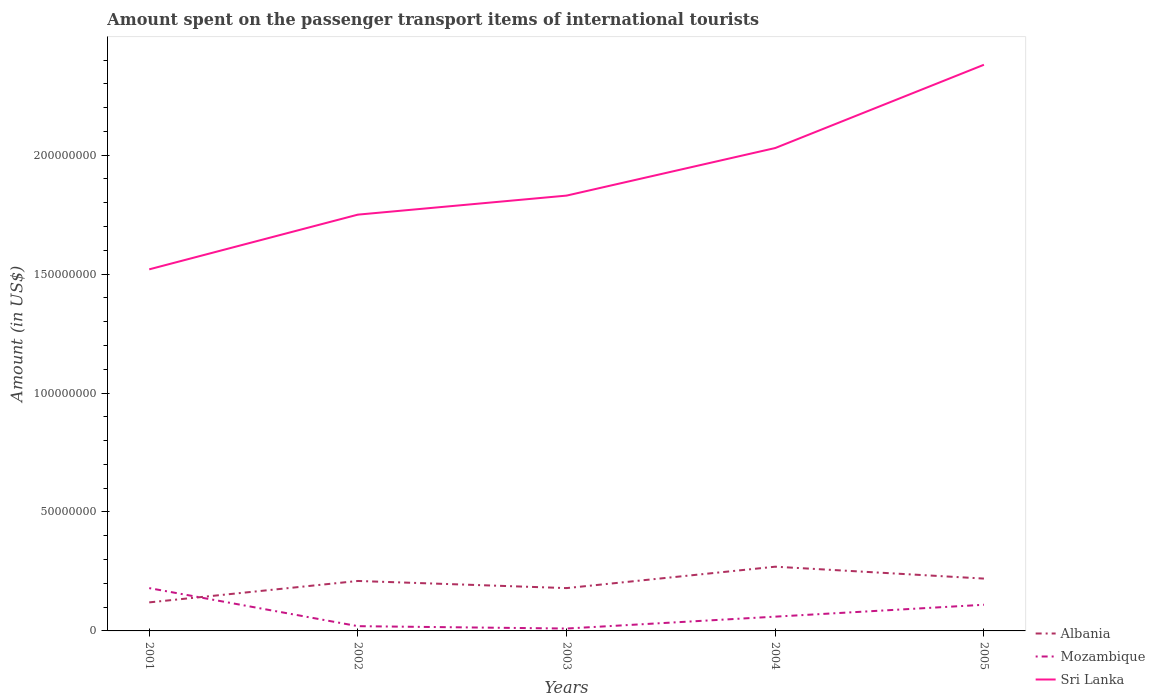Is the number of lines equal to the number of legend labels?
Ensure brevity in your answer.  Yes. Across all years, what is the maximum amount spent on the passenger transport items of international tourists in Mozambique?
Offer a terse response. 1.00e+06. In which year was the amount spent on the passenger transport items of international tourists in Mozambique maximum?
Ensure brevity in your answer.  2003. What is the total amount spent on the passenger transport items of international tourists in Albania in the graph?
Your answer should be very brief. -4.00e+06. What is the difference between the highest and the second highest amount spent on the passenger transport items of international tourists in Mozambique?
Make the answer very short. 1.70e+07. What is the difference between the highest and the lowest amount spent on the passenger transport items of international tourists in Mozambique?
Make the answer very short. 2. How many lines are there?
Offer a terse response. 3. What is the difference between two consecutive major ticks on the Y-axis?
Ensure brevity in your answer.  5.00e+07. Does the graph contain grids?
Keep it short and to the point. No. What is the title of the graph?
Your answer should be very brief. Amount spent on the passenger transport items of international tourists. What is the label or title of the X-axis?
Provide a short and direct response. Years. What is the label or title of the Y-axis?
Keep it short and to the point. Amount (in US$). What is the Amount (in US$) of Mozambique in 2001?
Your answer should be compact. 1.80e+07. What is the Amount (in US$) of Sri Lanka in 2001?
Offer a terse response. 1.52e+08. What is the Amount (in US$) of Albania in 2002?
Offer a very short reply. 2.10e+07. What is the Amount (in US$) of Sri Lanka in 2002?
Provide a short and direct response. 1.75e+08. What is the Amount (in US$) in Albania in 2003?
Ensure brevity in your answer.  1.80e+07. What is the Amount (in US$) of Mozambique in 2003?
Provide a short and direct response. 1.00e+06. What is the Amount (in US$) in Sri Lanka in 2003?
Ensure brevity in your answer.  1.83e+08. What is the Amount (in US$) in Albania in 2004?
Keep it short and to the point. 2.70e+07. What is the Amount (in US$) in Sri Lanka in 2004?
Offer a very short reply. 2.03e+08. What is the Amount (in US$) of Albania in 2005?
Offer a very short reply. 2.20e+07. What is the Amount (in US$) in Mozambique in 2005?
Ensure brevity in your answer.  1.10e+07. What is the Amount (in US$) of Sri Lanka in 2005?
Give a very brief answer. 2.38e+08. Across all years, what is the maximum Amount (in US$) in Albania?
Ensure brevity in your answer.  2.70e+07. Across all years, what is the maximum Amount (in US$) in Mozambique?
Offer a very short reply. 1.80e+07. Across all years, what is the maximum Amount (in US$) of Sri Lanka?
Your answer should be very brief. 2.38e+08. Across all years, what is the minimum Amount (in US$) in Mozambique?
Your response must be concise. 1.00e+06. Across all years, what is the minimum Amount (in US$) of Sri Lanka?
Make the answer very short. 1.52e+08. What is the total Amount (in US$) in Mozambique in the graph?
Your answer should be compact. 3.80e+07. What is the total Amount (in US$) in Sri Lanka in the graph?
Offer a very short reply. 9.51e+08. What is the difference between the Amount (in US$) in Albania in 2001 and that in 2002?
Make the answer very short. -9.00e+06. What is the difference between the Amount (in US$) of Mozambique in 2001 and that in 2002?
Your answer should be very brief. 1.60e+07. What is the difference between the Amount (in US$) of Sri Lanka in 2001 and that in 2002?
Your response must be concise. -2.30e+07. What is the difference between the Amount (in US$) of Albania in 2001 and that in 2003?
Offer a very short reply. -6.00e+06. What is the difference between the Amount (in US$) in Mozambique in 2001 and that in 2003?
Give a very brief answer. 1.70e+07. What is the difference between the Amount (in US$) in Sri Lanka in 2001 and that in 2003?
Provide a succinct answer. -3.10e+07. What is the difference between the Amount (in US$) in Albania in 2001 and that in 2004?
Provide a short and direct response. -1.50e+07. What is the difference between the Amount (in US$) of Sri Lanka in 2001 and that in 2004?
Keep it short and to the point. -5.10e+07. What is the difference between the Amount (in US$) of Albania in 2001 and that in 2005?
Your response must be concise. -1.00e+07. What is the difference between the Amount (in US$) of Mozambique in 2001 and that in 2005?
Your answer should be compact. 7.00e+06. What is the difference between the Amount (in US$) in Sri Lanka in 2001 and that in 2005?
Ensure brevity in your answer.  -8.60e+07. What is the difference between the Amount (in US$) in Mozambique in 2002 and that in 2003?
Give a very brief answer. 1.00e+06. What is the difference between the Amount (in US$) in Sri Lanka in 2002 and that in 2003?
Make the answer very short. -8.00e+06. What is the difference between the Amount (in US$) of Albania in 2002 and that in 2004?
Offer a terse response. -6.00e+06. What is the difference between the Amount (in US$) of Mozambique in 2002 and that in 2004?
Ensure brevity in your answer.  -4.00e+06. What is the difference between the Amount (in US$) of Sri Lanka in 2002 and that in 2004?
Provide a succinct answer. -2.80e+07. What is the difference between the Amount (in US$) of Mozambique in 2002 and that in 2005?
Provide a succinct answer. -9.00e+06. What is the difference between the Amount (in US$) in Sri Lanka in 2002 and that in 2005?
Offer a very short reply. -6.30e+07. What is the difference between the Amount (in US$) of Albania in 2003 and that in 2004?
Offer a very short reply. -9.00e+06. What is the difference between the Amount (in US$) of Mozambique in 2003 and that in 2004?
Keep it short and to the point. -5.00e+06. What is the difference between the Amount (in US$) in Sri Lanka in 2003 and that in 2004?
Offer a terse response. -2.00e+07. What is the difference between the Amount (in US$) in Mozambique in 2003 and that in 2005?
Make the answer very short. -1.00e+07. What is the difference between the Amount (in US$) of Sri Lanka in 2003 and that in 2005?
Your response must be concise. -5.50e+07. What is the difference between the Amount (in US$) of Albania in 2004 and that in 2005?
Offer a terse response. 5.00e+06. What is the difference between the Amount (in US$) of Mozambique in 2004 and that in 2005?
Offer a very short reply. -5.00e+06. What is the difference between the Amount (in US$) in Sri Lanka in 2004 and that in 2005?
Give a very brief answer. -3.50e+07. What is the difference between the Amount (in US$) in Albania in 2001 and the Amount (in US$) in Sri Lanka in 2002?
Give a very brief answer. -1.63e+08. What is the difference between the Amount (in US$) in Mozambique in 2001 and the Amount (in US$) in Sri Lanka in 2002?
Give a very brief answer. -1.57e+08. What is the difference between the Amount (in US$) of Albania in 2001 and the Amount (in US$) of Mozambique in 2003?
Your response must be concise. 1.10e+07. What is the difference between the Amount (in US$) of Albania in 2001 and the Amount (in US$) of Sri Lanka in 2003?
Make the answer very short. -1.71e+08. What is the difference between the Amount (in US$) of Mozambique in 2001 and the Amount (in US$) of Sri Lanka in 2003?
Offer a terse response. -1.65e+08. What is the difference between the Amount (in US$) of Albania in 2001 and the Amount (in US$) of Mozambique in 2004?
Your answer should be very brief. 6.00e+06. What is the difference between the Amount (in US$) in Albania in 2001 and the Amount (in US$) in Sri Lanka in 2004?
Provide a short and direct response. -1.91e+08. What is the difference between the Amount (in US$) of Mozambique in 2001 and the Amount (in US$) of Sri Lanka in 2004?
Your answer should be very brief. -1.85e+08. What is the difference between the Amount (in US$) in Albania in 2001 and the Amount (in US$) in Mozambique in 2005?
Provide a succinct answer. 1.00e+06. What is the difference between the Amount (in US$) in Albania in 2001 and the Amount (in US$) in Sri Lanka in 2005?
Your answer should be compact. -2.26e+08. What is the difference between the Amount (in US$) of Mozambique in 2001 and the Amount (in US$) of Sri Lanka in 2005?
Offer a very short reply. -2.20e+08. What is the difference between the Amount (in US$) in Albania in 2002 and the Amount (in US$) in Sri Lanka in 2003?
Your response must be concise. -1.62e+08. What is the difference between the Amount (in US$) in Mozambique in 2002 and the Amount (in US$) in Sri Lanka in 2003?
Provide a short and direct response. -1.81e+08. What is the difference between the Amount (in US$) in Albania in 2002 and the Amount (in US$) in Mozambique in 2004?
Provide a short and direct response. 1.50e+07. What is the difference between the Amount (in US$) in Albania in 2002 and the Amount (in US$) in Sri Lanka in 2004?
Provide a short and direct response. -1.82e+08. What is the difference between the Amount (in US$) of Mozambique in 2002 and the Amount (in US$) of Sri Lanka in 2004?
Make the answer very short. -2.01e+08. What is the difference between the Amount (in US$) of Albania in 2002 and the Amount (in US$) of Sri Lanka in 2005?
Your answer should be compact. -2.17e+08. What is the difference between the Amount (in US$) of Mozambique in 2002 and the Amount (in US$) of Sri Lanka in 2005?
Provide a succinct answer. -2.36e+08. What is the difference between the Amount (in US$) in Albania in 2003 and the Amount (in US$) in Sri Lanka in 2004?
Make the answer very short. -1.85e+08. What is the difference between the Amount (in US$) in Mozambique in 2003 and the Amount (in US$) in Sri Lanka in 2004?
Your response must be concise. -2.02e+08. What is the difference between the Amount (in US$) in Albania in 2003 and the Amount (in US$) in Mozambique in 2005?
Offer a very short reply. 7.00e+06. What is the difference between the Amount (in US$) of Albania in 2003 and the Amount (in US$) of Sri Lanka in 2005?
Your response must be concise. -2.20e+08. What is the difference between the Amount (in US$) of Mozambique in 2003 and the Amount (in US$) of Sri Lanka in 2005?
Provide a short and direct response. -2.37e+08. What is the difference between the Amount (in US$) of Albania in 2004 and the Amount (in US$) of Mozambique in 2005?
Provide a short and direct response. 1.60e+07. What is the difference between the Amount (in US$) of Albania in 2004 and the Amount (in US$) of Sri Lanka in 2005?
Offer a very short reply. -2.11e+08. What is the difference between the Amount (in US$) in Mozambique in 2004 and the Amount (in US$) in Sri Lanka in 2005?
Make the answer very short. -2.32e+08. What is the average Amount (in US$) in Albania per year?
Give a very brief answer. 2.00e+07. What is the average Amount (in US$) in Mozambique per year?
Offer a very short reply. 7.60e+06. What is the average Amount (in US$) of Sri Lanka per year?
Provide a succinct answer. 1.90e+08. In the year 2001, what is the difference between the Amount (in US$) of Albania and Amount (in US$) of Mozambique?
Give a very brief answer. -6.00e+06. In the year 2001, what is the difference between the Amount (in US$) in Albania and Amount (in US$) in Sri Lanka?
Ensure brevity in your answer.  -1.40e+08. In the year 2001, what is the difference between the Amount (in US$) in Mozambique and Amount (in US$) in Sri Lanka?
Provide a succinct answer. -1.34e+08. In the year 2002, what is the difference between the Amount (in US$) in Albania and Amount (in US$) in Mozambique?
Provide a succinct answer. 1.90e+07. In the year 2002, what is the difference between the Amount (in US$) in Albania and Amount (in US$) in Sri Lanka?
Your answer should be very brief. -1.54e+08. In the year 2002, what is the difference between the Amount (in US$) of Mozambique and Amount (in US$) of Sri Lanka?
Your response must be concise. -1.73e+08. In the year 2003, what is the difference between the Amount (in US$) in Albania and Amount (in US$) in Mozambique?
Offer a very short reply. 1.70e+07. In the year 2003, what is the difference between the Amount (in US$) in Albania and Amount (in US$) in Sri Lanka?
Provide a short and direct response. -1.65e+08. In the year 2003, what is the difference between the Amount (in US$) of Mozambique and Amount (in US$) of Sri Lanka?
Provide a succinct answer. -1.82e+08. In the year 2004, what is the difference between the Amount (in US$) of Albania and Amount (in US$) of Mozambique?
Your answer should be compact. 2.10e+07. In the year 2004, what is the difference between the Amount (in US$) of Albania and Amount (in US$) of Sri Lanka?
Make the answer very short. -1.76e+08. In the year 2004, what is the difference between the Amount (in US$) of Mozambique and Amount (in US$) of Sri Lanka?
Ensure brevity in your answer.  -1.97e+08. In the year 2005, what is the difference between the Amount (in US$) in Albania and Amount (in US$) in Mozambique?
Offer a very short reply. 1.10e+07. In the year 2005, what is the difference between the Amount (in US$) in Albania and Amount (in US$) in Sri Lanka?
Make the answer very short. -2.16e+08. In the year 2005, what is the difference between the Amount (in US$) of Mozambique and Amount (in US$) of Sri Lanka?
Offer a terse response. -2.27e+08. What is the ratio of the Amount (in US$) of Albania in 2001 to that in 2002?
Your answer should be very brief. 0.57. What is the ratio of the Amount (in US$) of Sri Lanka in 2001 to that in 2002?
Ensure brevity in your answer.  0.87. What is the ratio of the Amount (in US$) in Mozambique in 2001 to that in 2003?
Make the answer very short. 18. What is the ratio of the Amount (in US$) in Sri Lanka in 2001 to that in 2003?
Give a very brief answer. 0.83. What is the ratio of the Amount (in US$) in Albania in 2001 to that in 2004?
Your answer should be very brief. 0.44. What is the ratio of the Amount (in US$) of Mozambique in 2001 to that in 2004?
Ensure brevity in your answer.  3. What is the ratio of the Amount (in US$) of Sri Lanka in 2001 to that in 2004?
Ensure brevity in your answer.  0.75. What is the ratio of the Amount (in US$) in Albania in 2001 to that in 2005?
Provide a short and direct response. 0.55. What is the ratio of the Amount (in US$) of Mozambique in 2001 to that in 2005?
Offer a terse response. 1.64. What is the ratio of the Amount (in US$) of Sri Lanka in 2001 to that in 2005?
Keep it short and to the point. 0.64. What is the ratio of the Amount (in US$) in Mozambique in 2002 to that in 2003?
Your response must be concise. 2. What is the ratio of the Amount (in US$) of Sri Lanka in 2002 to that in 2003?
Offer a very short reply. 0.96. What is the ratio of the Amount (in US$) of Albania in 2002 to that in 2004?
Give a very brief answer. 0.78. What is the ratio of the Amount (in US$) of Sri Lanka in 2002 to that in 2004?
Offer a terse response. 0.86. What is the ratio of the Amount (in US$) in Albania in 2002 to that in 2005?
Keep it short and to the point. 0.95. What is the ratio of the Amount (in US$) in Mozambique in 2002 to that in 2005?
Provide a succinct answer. 0.18. What is the ratio of the Amount (in US$) in Sri Lanka in 2002 to that in 2005?
Ensure brevity in your answer.  0.74. What is the ratio of the Amount (in US$) in Sri Lanka in 2003 to that in 2004?
Your response must be concise. 0.9. What is the ratio of the Amount (in US$) of Albania in 2003 to that in 2005?
Provide a short and direct response. 0.82. What is the ratio of the Amount (in US$) of Mozambique in 2003 to that in 2005?
Make the answer very short. 0.09. What is the ratio of the Amount (in US$) of Sri Lanka in 2003 to that in 2005?
Your answer should be compact. 0.77. What is the ratio of the Amount (in US$) of Albania in 2004 to that in 2005?
Offer a very short reply. 1.23. What is the ratio of the Amount (in US$) in Mozambique in 2004 to that in 2005?
Offer a terse response. 0.55. What is the ratio of the Amount (in US$) in Sri Lanka in 2004 to that in 2005?
Keep it short and to the point. 0.85. What is the difference between the highest and the second highest Amount (in US$) of Sri Lanka?
Make the answer very short. 3.50e+07. What is the difference between the highest and the lowest Amount (in US$) of Albania?
Make the answer very short. 1.50e+07. What is the difference between the highest and the lowest Amount (in US$) of Mozambique?
Provide a short and direct response. 1.70e+07. What is the difference between the highest and the lowest Amount (in US$) in Sri Lanka?
Your answer should be very brief. 8.60e+07. 